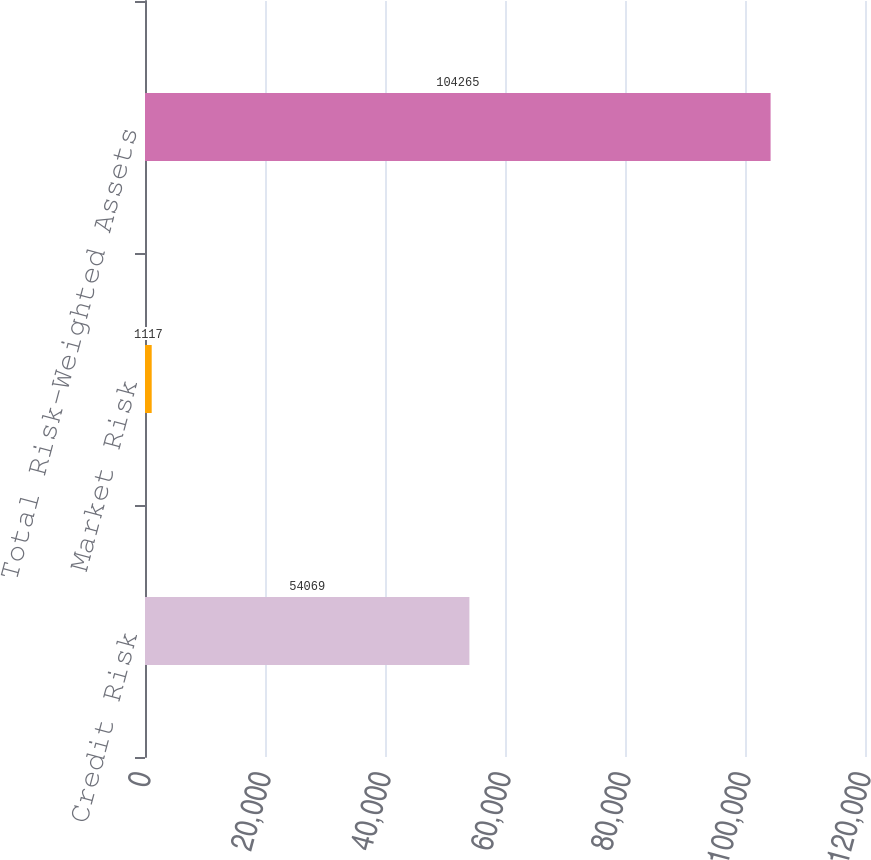<chart> <loc_0><loc_0><loc_500><loc_500><bar_chart><fcel>Credit Risk<fcel>Market Risk<fcel>Total Risk-Weighted Assets<nl><fcel>54069<fcel>1117<fcel>104265<nl></chart> 